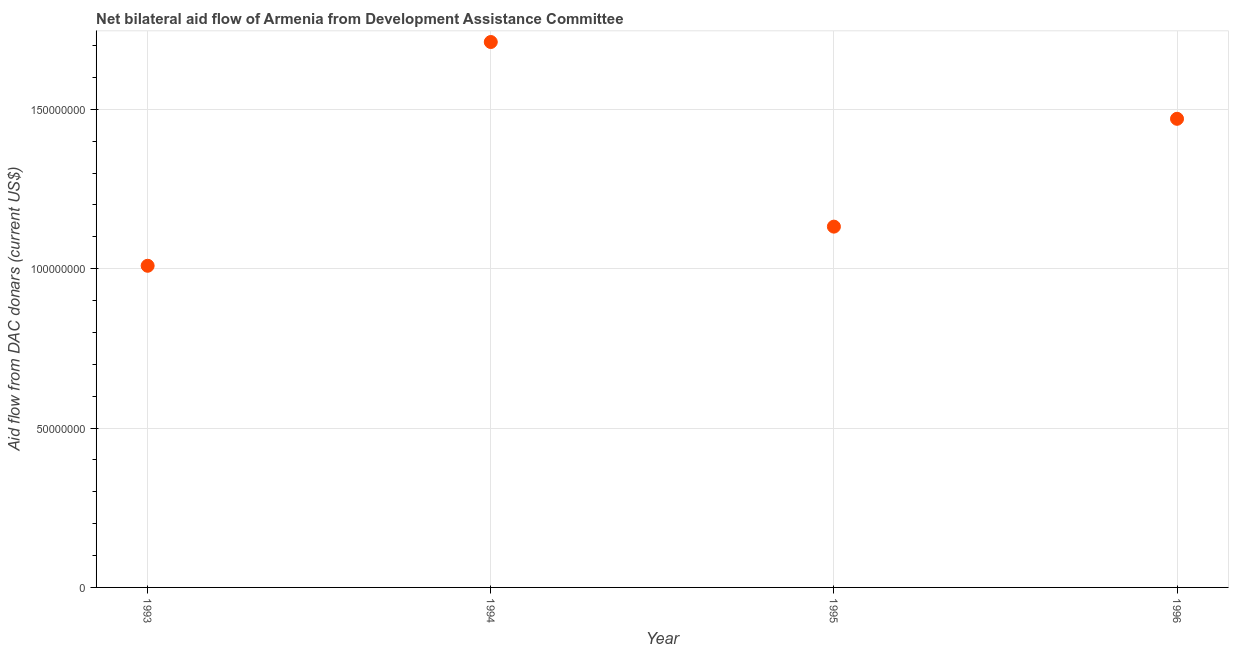What is the net bilateral aid flows from dac donors in 1995?
Ensure brevity in your answer.  1.13e+08. Across all years, what is the maximum net bilateral aid flows from dac donors?
Your answer should be compact. 1.71e+08. Across all years, what is the minimum net bilateral aid flows from dac donors?
Offer a terse response. 1.01e+08. In which year was the net bilateral aid flows from dac donors minimum?
Offer a terse response. 1993. What is the sum of the net bilateral aid flows from dac donors?
Ensure brevity in your answer.  5.32e+08. What is the difference between the net bilateral aid flows from dac donors in 1994 and 1996?
Keep it short and to the point. 2.41e+07. What is the average net bilateral aid flows from dac donors per year?
Provide a short and direct response. 1.33e+08. What is the median net bilateral aid flows from dac donors?
Keep it short and to the point. 1.30e+08. In how many years, is the net bilateral aid flows from dac donors greater than 120000000 US$?
Provide a short and direct response. 2. What is the ratio of the net bilateral aid flows from dac donors in 1994 to that in 1995?
Your response must be concise. 1.51. Is the net bilateral aid flows from dac donors in 1993 less than that in 1994?
Provide a short and direct response. Yes. Is the difference between the net bilateral aid flows from dac donors in 1993 and 1994 greater than the difference between any two years?
Give a very brief answer. Yes. What is the difference between the highest and the second highest net bilateral aid flows from dac donors?
Keep it short and to the point. 2.41e+07. What is the difference between the highest and the lowest net bilateral aid flows from dac donors?
Your answer should be compact. 7.02e+07. In how many years, is the net bilateral aid flows from dac donors greater than the average net bilateral aid flows from dac donors taken over all years?
Offer a terse response. 2. Does the net bilateral aid flows from dac donors monotonically increase over the years?
Your answer should be compact. No. How many dotlines are there?
Your answer should be very brief. 1. How many years are there in the graph?
Your answer should be compact. 4. What is the difference between two consecutive major ticks on the Y-axis?
Offer a terse response. 5.00e+07. Are the values on the major ticks of Y-axis written in scientific E-notation?
Give a very brief answer. No. Does the graph contain any zero values?
Offer a very short reply. No. Does the graph contain grids?
Make the answer very short. Yes. What is the title of the graph?
Provide a succinct answer. Net bilateral aid flow of Armenia from Development Assistance Committee. What is the label or title of the Y-axis?
Keep it short and to the point. Aid flow from DAC donars (current US$). What is the Aid flow from DAC donars (current US$) in 1993?
Provide a succinct answer. 1.01e+08. What is the Aid flow from DAC donars (current US$) in 1994?
Ensure brevity in your answer.  1.71e+08. What is the Aid flow from DAC donars (current US$) in 1995?
Offer a terse response. 1.13e+08. What is the Aid flow from DAC donars (current US$) in 1996?
Keep it short and to the point. 1.47e+08. What is the difference between the Aid flow from DAC donars (current US$) in 1993 and 1994?
Provide a short and direct response. -7.02e+07. What is the difference between the Aid flow from DAC donars (current US$) in 1993 and 1995?
Ensure brevity in your answer.  -1.23e+07. What is the difference between the Aid flow from DAC donars (current US$) in 1993 and 1996?
Give a very brief answer. -4.61e+07. What is the difference between the Aid flow from DAC donars (current US$) in 1994 and 1995?
Your answer should be compact. 5.79e+07. What is the difference between the Aid flow from DAC donars (current US$) in 1994 and 1996?
Give a very brief answer. 2.41e+07. What is the difference between the Aid flow from DAC donars (current US$) in 1995 and 1996?
Your answer should be compact. -3.38e+07. What is the ratio of the Aid flow from DAC donars (current US$) in 1993 to that in 1994?
Offer a very short reply. 0.59. What is the ratio of the Aid flow from DAC donars (current US$) in 1993 to that in 1995?
Your response must be concise. 0.89. What is the ratio of the Aid flow from DAC donars (current US$) in 1993 to that in 1996?
Make the answer very short. 0.69. What is the ratio of the Aid flow from DAC donars (current US$) in 1994 to that in 1995?
Provide a succinct answer. 1.51. What is the ratio of the Aid flow from DAC donars (current US$) in 1994 to that in 1996?
Offer a terse response. 1.16. What is the ratio of the Aid flow from DAC donars (current US$) in 1995 to that in 1996?
Provide a short and direct response. 0.77. 